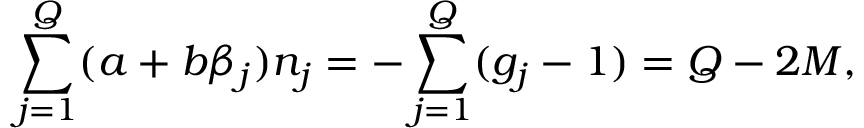<formula> <loc_0><loc_0><loc_500><loc_500>\sum _ { j = 1 } ^ { Q } ( a + b \beta _ { j } ) n _ { j } = - \sum _ { j = 1 } ^ { Q } ( g _ { j } - 1 ) = Q - 2 M ,</formula> 